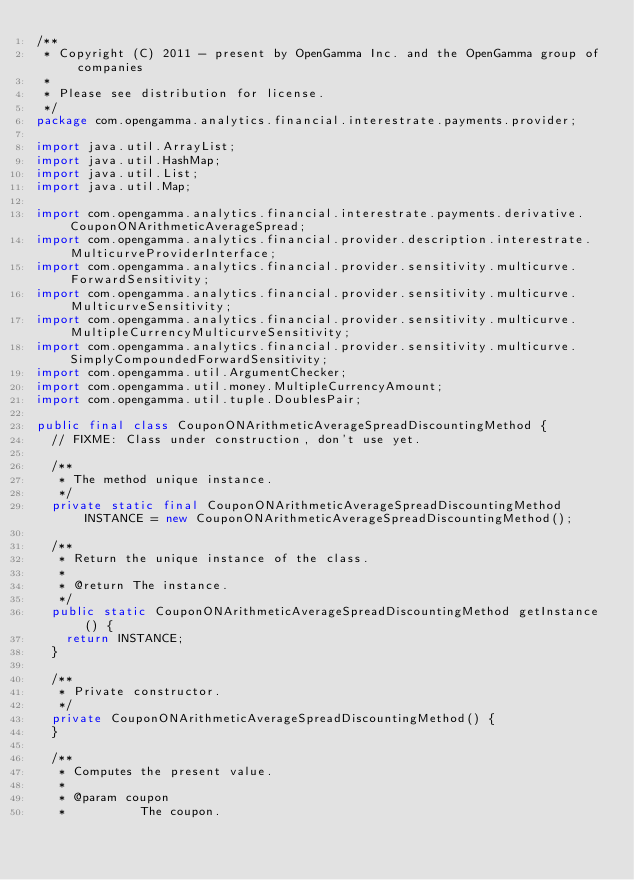<code> <loc_0><loc_0><loc_500><loc_500><_Java_>/**
 * Copyright (C) 2011 - present by OpenGamma Inc. and the OpenGamma group of companies
 *
 * Please see distribution for license.
 */
package com.opengamma.analytics.financial.interestrate.payments.provider;

import java.util.ArrayList;
import java.util.HashMap;
import java.util.List;
import java.util.Map;

import com.opengamma.analytics.financial.interestrate.payments.derivative.CouponONArithmeticAverageSpread;
import com.opengamma.analytics.financial.provider.description.interestrate.MulticurveProviderInterface;
import com.opengamma.analytics.financial.provider.sensitivity.multicurve.ForwardSensitivity;
import com.opengamma.analytics.financial.provider.sensitivity.multicurve.MulticurveSensitivity;
import com.opengamma.analytics.financial.provider.sensitivity.multicurve.MultipleCurrencyMulticurveSensitivity;
import com.opengamma.analytics.financial.provider.sensitivity.multicurve.SimplyCompoundedForwardSensitivity;
import com.opengamma.util.ArgumentChecker;
import com.opengamma.util.money.MultipleCurrencyAmount;
import com.opengamma.util.tuple.DoublesPair;

public final class CouponONArithmeticAverageSpreadDiscountingMethod {
  // FIXME: Class under construction, don't use yet.

  /**
   * The method unique instance.
   */
  private static final CouponONArithmeticAverageSpreadDiscountingMethod INSTANCE = new CouponONArithmeticAverageSpreadDiscountingMethod();

  /**
   * Return the unique instance of the class.
   * 
   * @return The instance.
   */
  public static CouponONArithmeticAverageSpreadDiscountingMethod getInstance() {
    return INSTANCE;
  }

  /**
   * Private constructor.
   */
  private CouponONArithmeticAverageSpreadDiscountingMethod() {
  }

  /**
   * Computes the present value.
   * 
   * @param coupon
   *          The coupon.</code> 